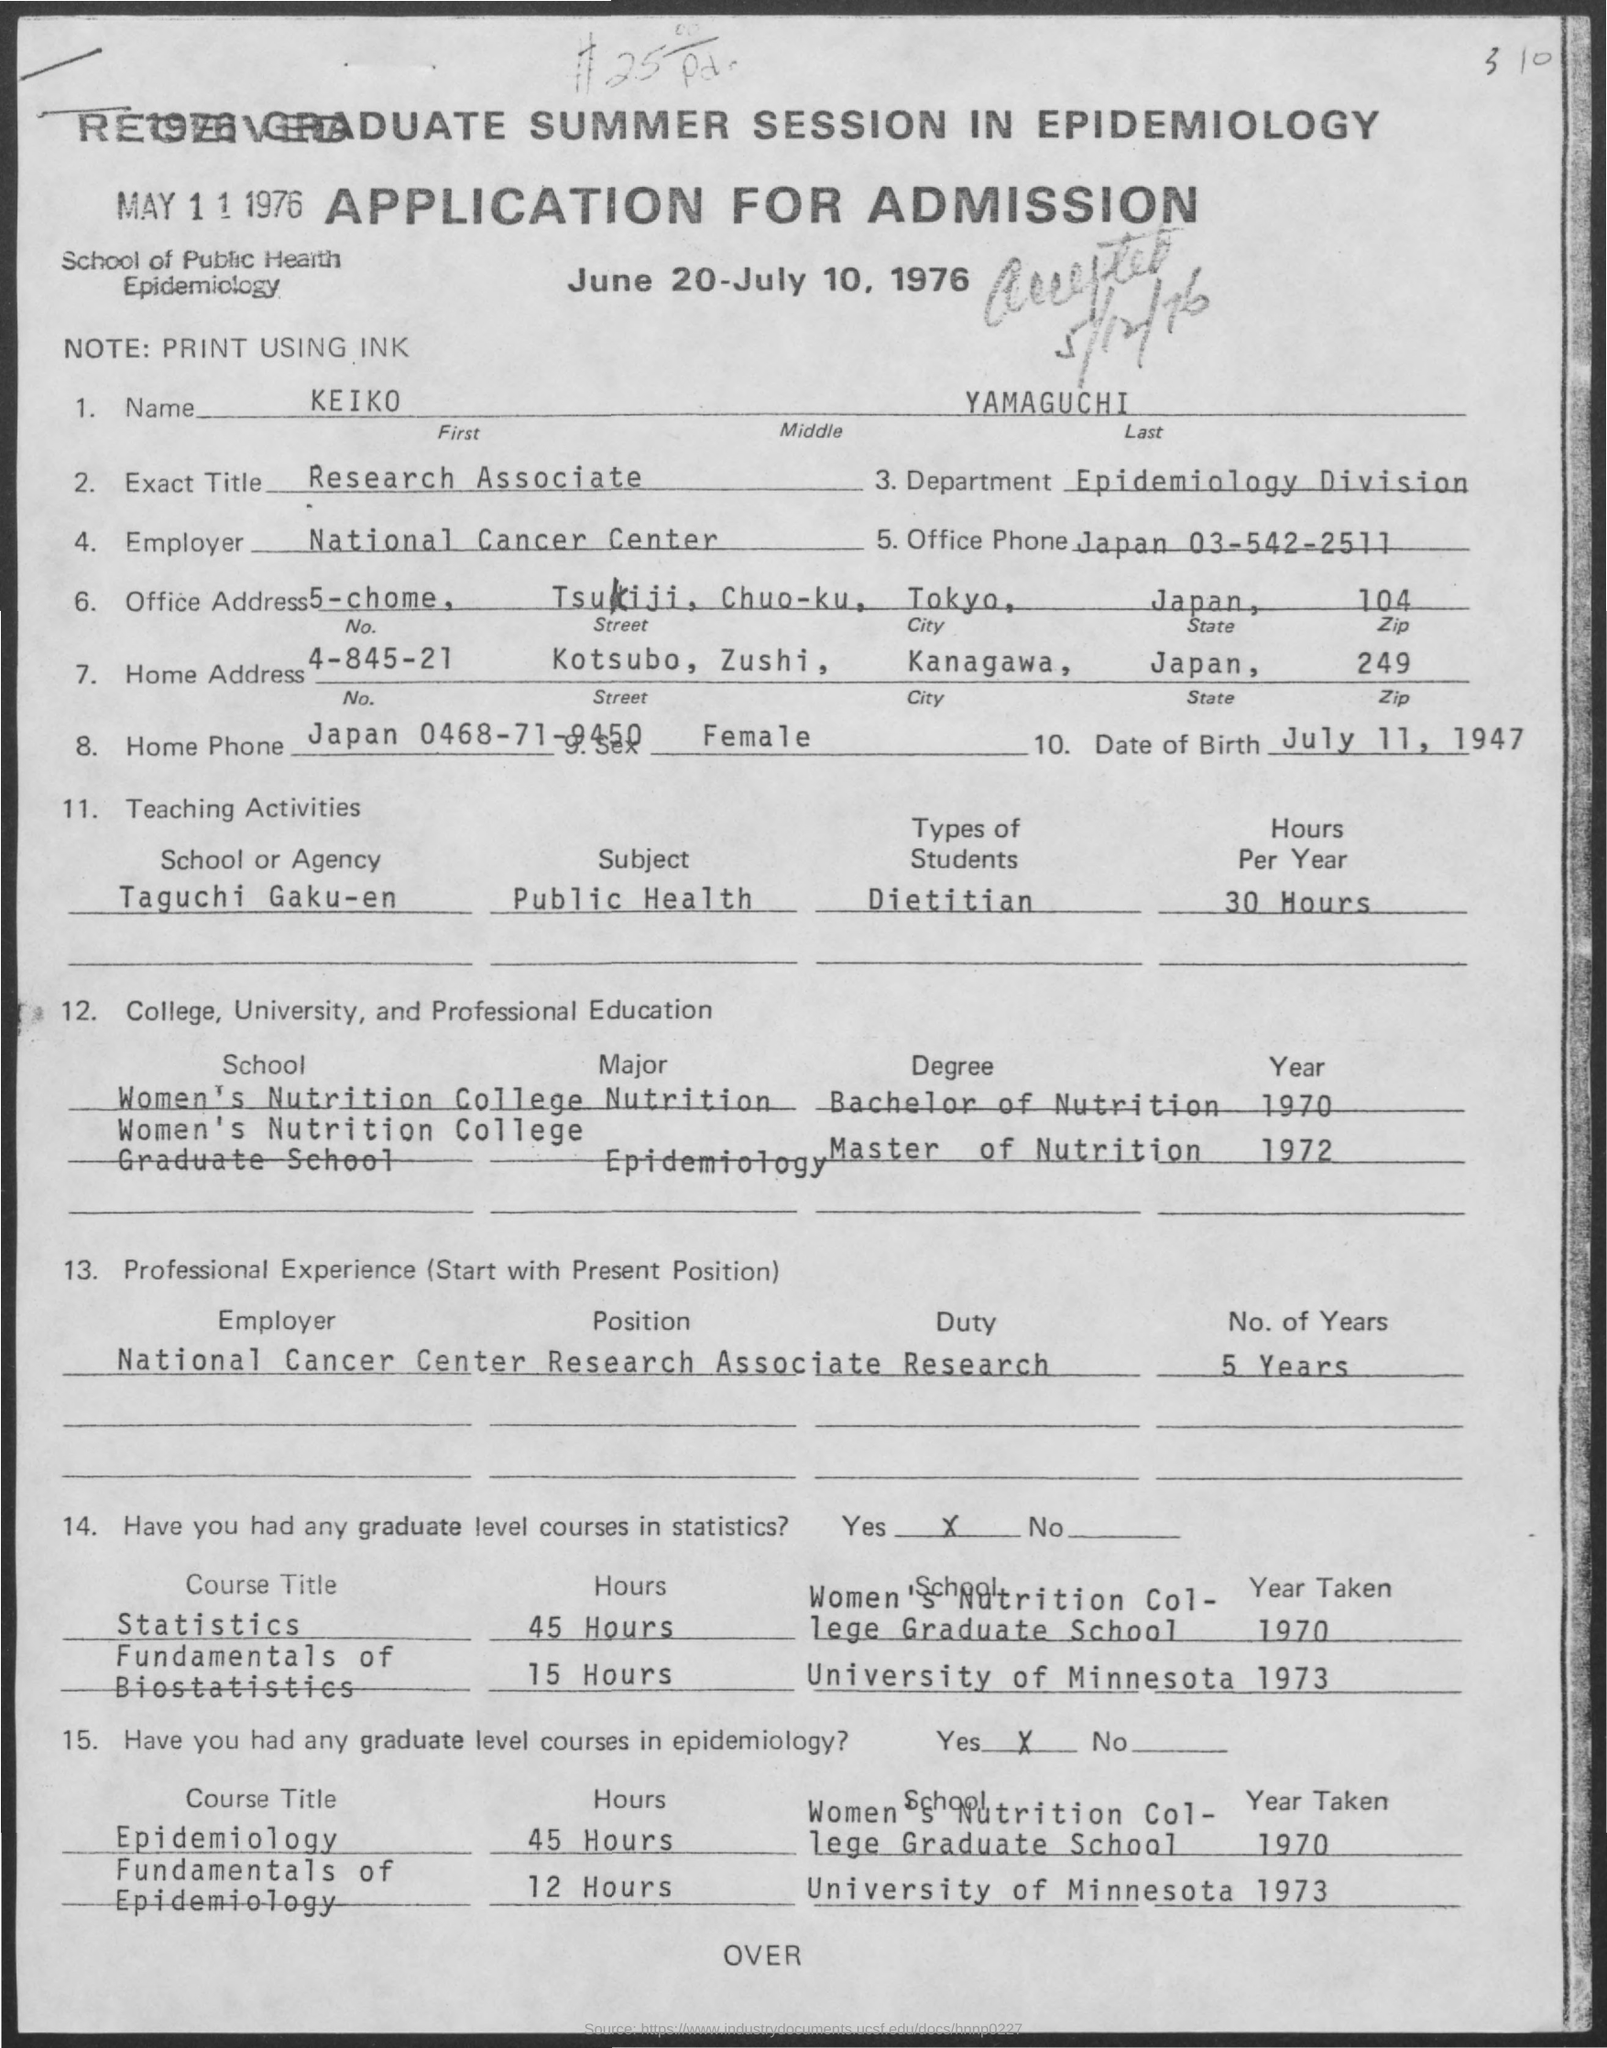Indicate a few pertinent items in this graphic. The Epidemiology Division is a department within the Department of Public Health. The name "Keiko" is the first name. The National Cancer Center is the employer of the individual in question. The date of birth is July 11, 1947. I am a research associate, specifically inquiring about the title of my position. 